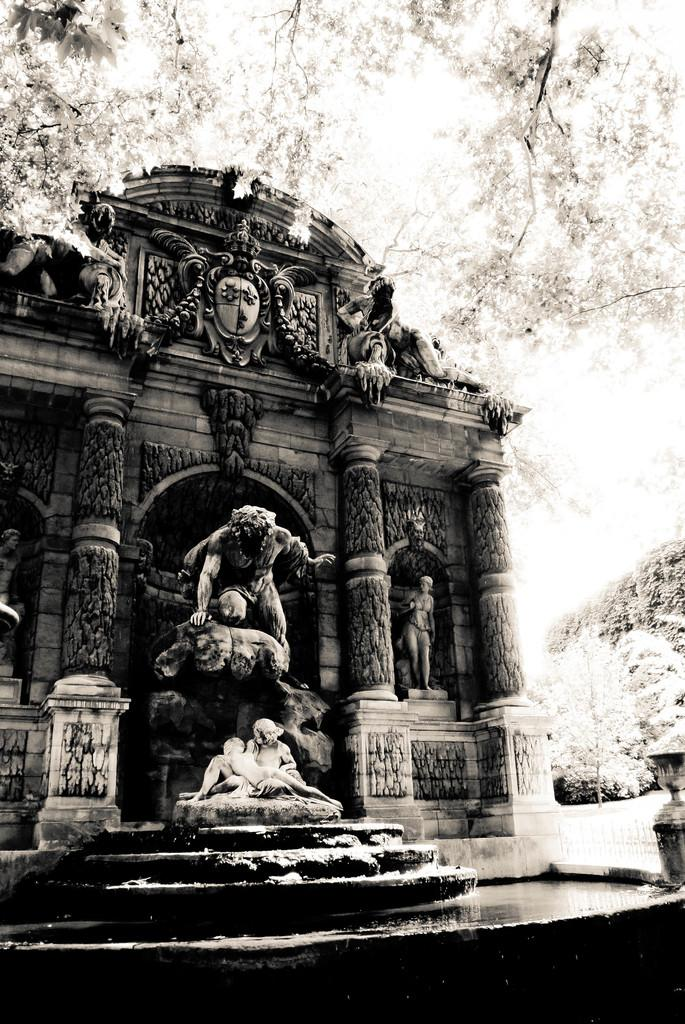What is the color scheme of the image? The image is black and white. What type of structure is present in the image? There is a building with sculptures in the image. What is located in front of the building? There is a statue fountain in front of the building. What can be seen in the background of the image? There are trees in the background of the image. What rule is being enforced by the statue in the image? There is no rule being enforced by the statue in the image, as it is a part of a statue fountain and not a person or authority figure. How many matches are visible in the image? There are no matches present in the image. 